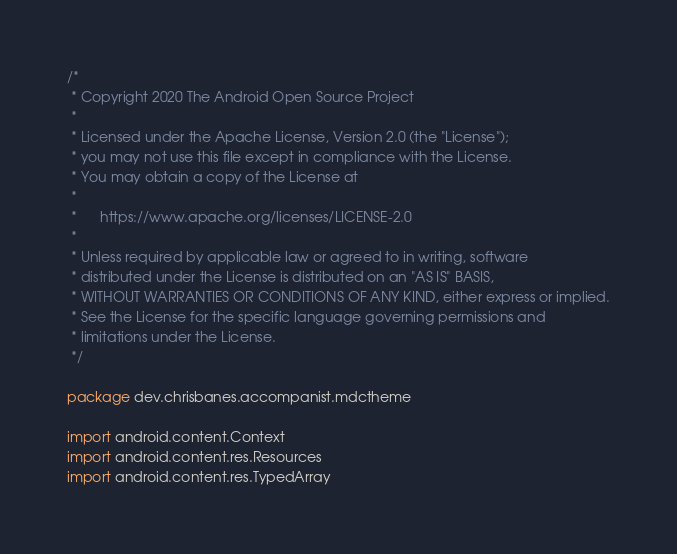Convert code to text. <code><loc_0><loc_0><loc_500><loc_500><_Kotlin_>/*
 * Copyright 2020 The Android Open Source Project
 *
 * Licensed under the Apache License, Version 2.0 (the "License");
 * you may not use this file except in compliance with the License.
 * You may obtain a copy of the License at
 *
 *      https://www.apache.org/licenses/LICENSE-2.0
 *
 * Unless required by applicable law or agreed to in writing, software
 * distributed under the License is distributed on an "AS IS" BASIS,
 * WITHOUT WARRANTIES OR CONDITIONS OF ANY KIND, either express or implied.
 * See the License for the specific language governing permissions and
 * limitations under the License.
 */

package dev.chrisbanes.accompanist.mdctheme

import android.content.Context
import android.content.res.Resources
import android.content.res.TypedArray</code> 